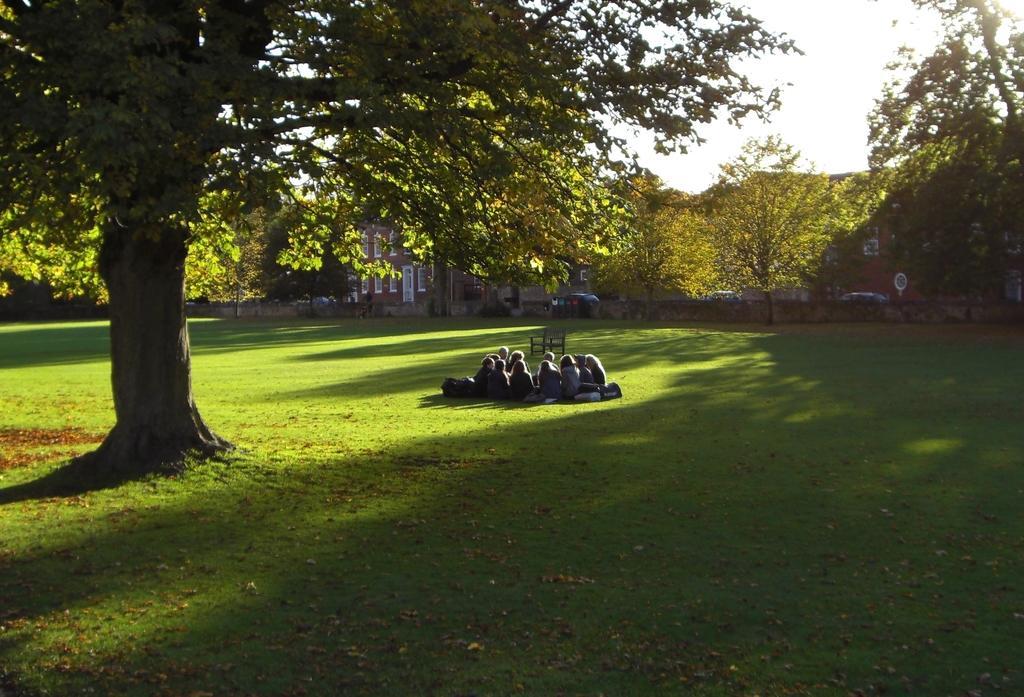Please provide a concise description of this image. In this picture there are group of people sitting on the grass and there is a chair on the grass. At the back there are vehicles, buildings and trees. At the top there is sky. At the bottom there is grass. 